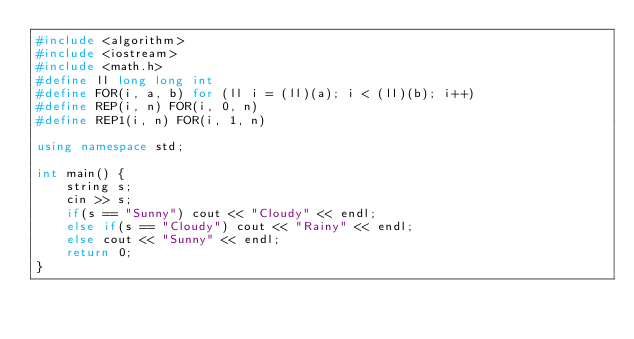Convert code to text. <code><loc_0><loc_0><loc_500><loc_500><_C++_>#include <algorithm>
#include <iostream>
#include <math.h>
#define ll long long int
#define FOR(i, a, b) for (ll i = (ll)(a); i < (ll)(b); i++)
#define REP(i, n) FOR(i, 0, n)
#define REP1(i, n) FOR(i, 1, n)

using namespace std;

int main() {
    string s;
    cin >> s;
    if(s == "Sunny") cout << "Cloudy" << endl;
    else if(s == "Cloudy") cout << "Rainy" << endl;
    else cout << "Sunny" << endl;
    return 0;
}
</code> 